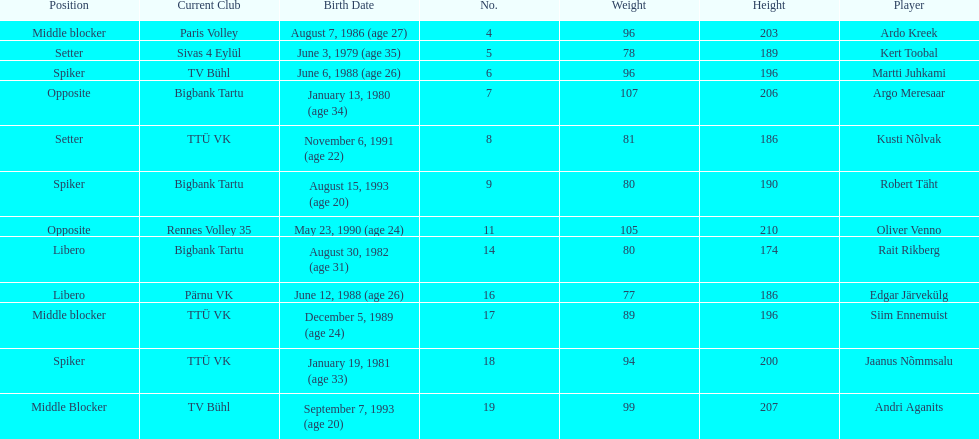How many players are middle blockers? 3. 